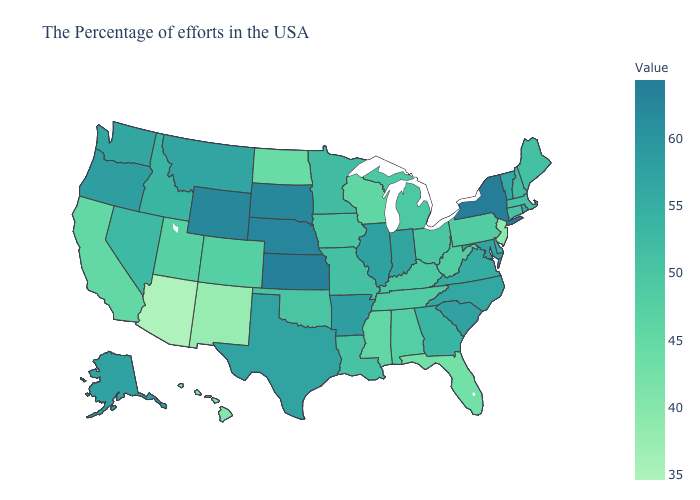Is the legend a continuous bar?
Write a very short answer. Yes. Does the map have missing data?
Write a very short answer. No. Among the states that border New Jersey , which have the lowest value?
Be succinct. Pennsylvania. Does the map have missing data?
Answer briefly. No. Among the states that border New Hampshire , which have the highest value?
Keep it brief. Vermont. Does Kansas have the highest value in the MidWest?
Short answer required. Yes. 